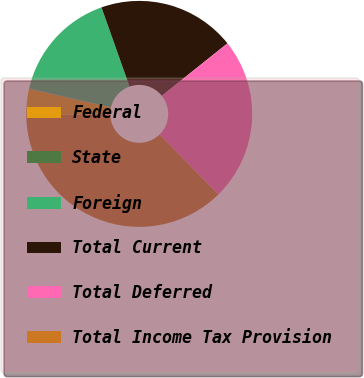Convert chart to OTSL. <chart><loc_0><loc_0><loc_500><loc_500><pie_chart><fcel>Federal<fcel>State<fcel>Foreign<fcel>Total Current<fcel>Total Deferred<fcel>Total Income Tax Provision<nl><fcel>3.76%<fcel>0.05%<fcel>15.98%<fcel>19.69%<fcel>23.39%<fcel>37.13%<nl></chart> 